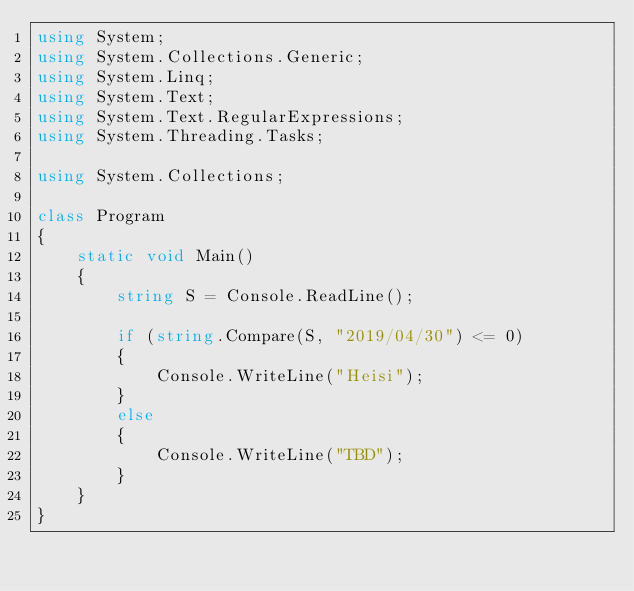Convert code to text. <code><loc_0><loc_0><loc_500><loc_500><_C#_>using System;
using System.Collections.Generic;
using System.Linq;
using System.Text;
using System.Text.RegularExpressions;
using System.Threading.Tasks;

using System.Collections;

class Program
{
    static void Main()
    {
        string S = Console.ReadLine();

        if (string.Compare(S, "2019/04/30") <= 0)
        {
            Console.WriteLine("Heisi");
        }
        else
        {
            Console.WriteLine("TBD");
        }
    }
}
</code> 